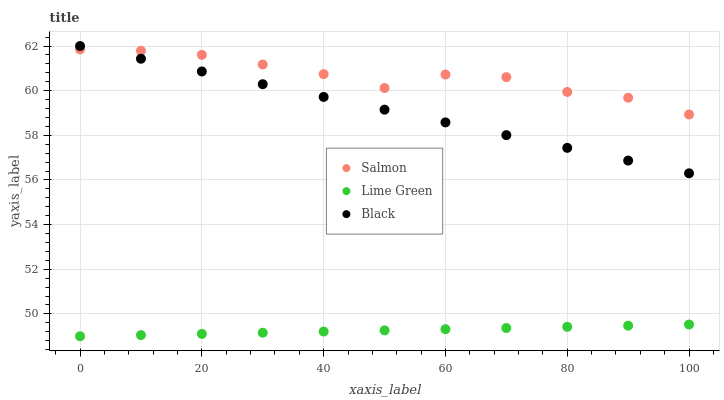Does Lime Green have the minimum area under the curve?
Answer yes or no. Yes. Does Salmon have the maximum area under the curve?
Answer yes or no. Yes. Does Black have the minimum area under the curve?
Answer yes or no. No. Does Black have the maximum area under the curve?
Answer yes or no. No. Is Lime Green the smoothest?
Answer yes or no. Yes. Is Salmon the roughest?
Answer yes or no. Yes. Is Black the smoothest?
Answer yes or no. No. Is Black the roughest?
Answer yes or no. No. Does Lime Green have the lowest value?
Answer yes or no. Yes. Does Black have the lowest value?
Answer yes or no. No. Does Black have the highest value?
Answer yes or no. Yes. Does Salmon have the highest value?
Answer yes or no. No. Is Lime Green less than Black?
Answer yes or no. Yes. Is Salmon greater than Lime Green?
Answer yes or no. Yes. Does Salmon intersect Black?
Answer yes or no. Yes. Is Salmon less than Black?
Answer yes or no. No. Is Salmon greater than Black?
Answer yes or no. No. Does Lime Green intersect Black?
Answer yes or no. No. 